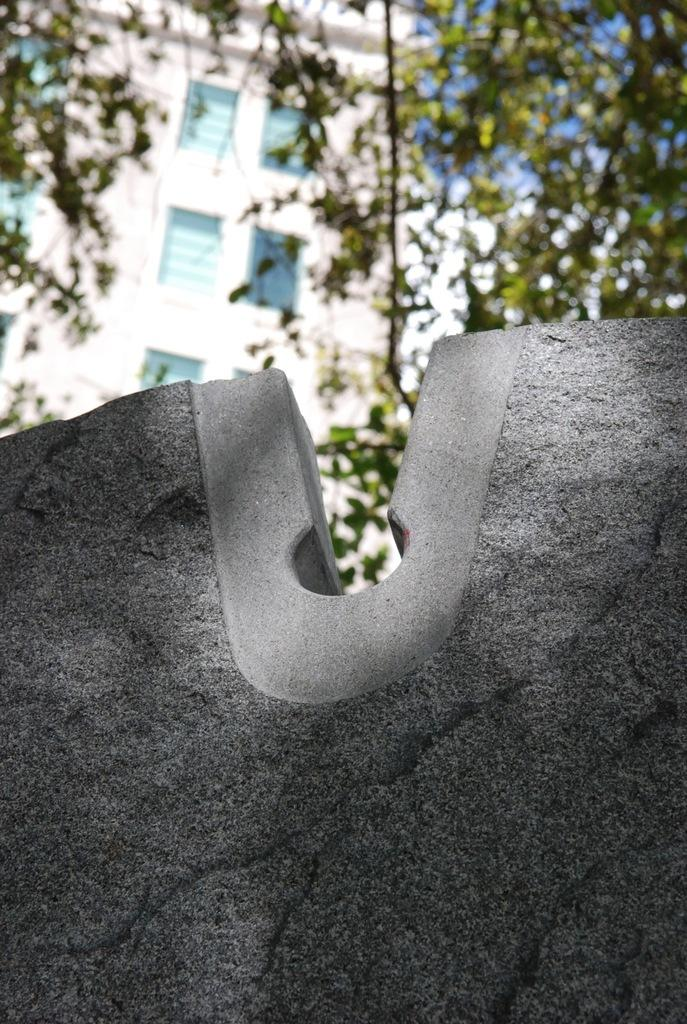What is the main subject in the image? There is a rock in the image. What can be seen behind the rock? There are buildings and trees behind the rock. How many balls are visible on the rock in the image? There are no balls present on the rock in the image. What type of boot is placed on the rock in the image? There is no boot present on the rock in the image. 